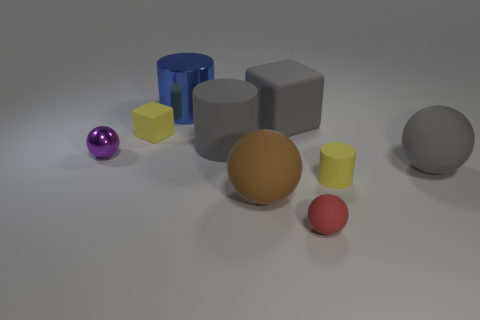What size is the purple thing that is the same shape as the tiny red rubber thing?
Your answer should be very brief. Small. The metal object that is the same size as the gray matte cube is what color?
Provide a short and direct response. Blue. Do the rubber object left of the gray matte cylinder and the gray matte ball that is on the right side of the big blue cylinder have the same size?
Keep it short and to the point. No. There is a yellow object right of the tiny sphere that is on the right side of the yellow matte thing to the left of the small matte cylinder; what is its size?
Keep it short and to the point. Small. The small yellow thing that is behind the yellow thing on the right side of the large metallic thing is what shape?
Give a very brief answer. Cube. There is a tiny matte thing that is on the left side of the blue metal object; does it have the same color as the tiny metal object?
Provide a succinct answer. No. There is a large thing that is both to the right of the brown thing and behind the purple sphere; what color is it?
Your answer should be very brief. Gray. Is there a yellow cube that has the same material as the gray block?
Make the answer very short. Yes. What is the size of the purple sphere?
Offer a terse response. Small. What is the size of the shiny object that is left of the big cylinder that is behind the small yellow matte cube?
Ensure brevity in your answer.  Small. 